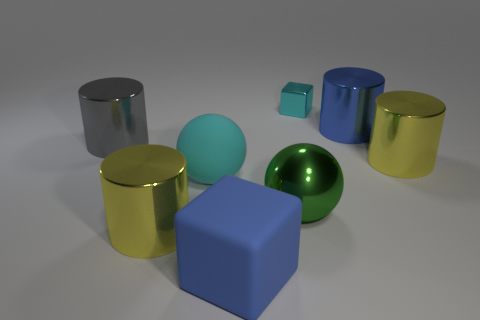There is a cylinder that is the same color as the big rubber block; what is its size?
Provide a succinct answer. Large. What is the shape of the big matte object that is the same color as the small thing?
Make the answer very short. Sphere. There is a shiny cylinder that is both to the right of the tiny cyan shiny block and in front of the big gray cylinder; what is its size?
Make the answer very short. Large. There is a large metal cylinder in front of the metallic sphere; is its color the same as the ball on the right side of the big blue block?
Your response must be concise. No. How many other objects are the same material as the gray thing?
Ensure brevity in your answer.  5. The thing that is behind the large gray metallic cylinder and in front of the small cyan shiny cube has what shape?
Make the answer very short. Cylinder. There is a big cube; does it have the same color as the metallic object in front of the metallic sphere?
Give a very brief answer. No. There is a block that is behind the rubber ball; is its size the same as the large cube?
Give a very brief answer. No. What is the material of the other thing that is the same shape as the cyan matte object?
Offer a very short reply. Metal. Is the blue metal thing the same shape as the green metal object?
Your response must be concise. No. 